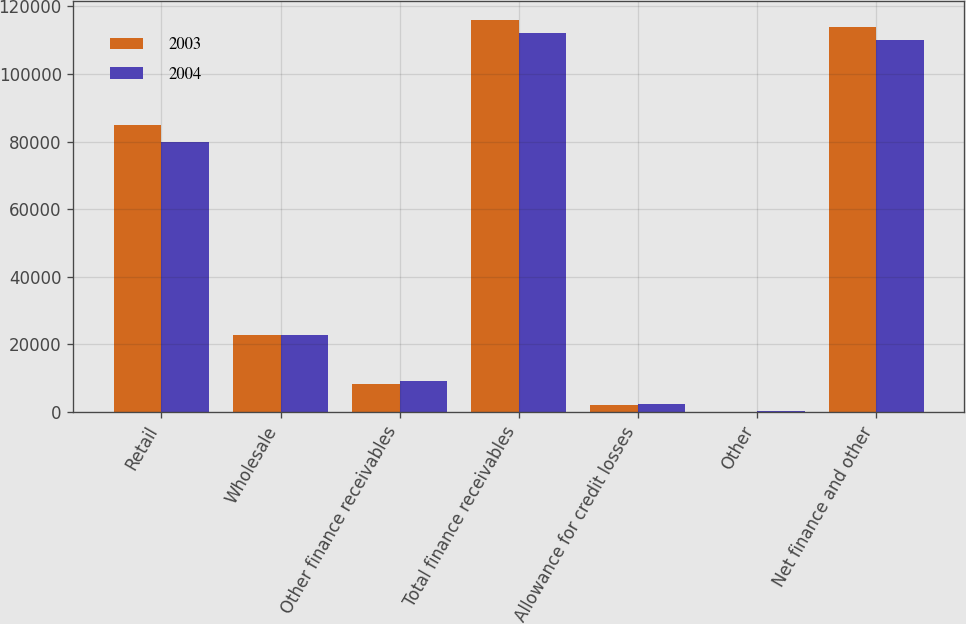Convert chart. <chart><loc_0><loc_0><loc_500><loc_500><stacked_bar_chart><ecel><fcel>Retail<fcel>Wholesale<fcel>Other finance receivables<fcel>Total finance receivables<fcel>Allowance for credit losses<fcel>Other<fcel>Net finance and other<nl><fcel>2003<fcel>84843<fcel>22666<fcel>8409<fcel>115918<fcel>2166<fcel>72<fcel>113824<nl><fcel>2004<fcel>80017<fcel>22910<fcel>9083<fcel>112010<fcel>2338<fcel>331<fcel>110003<nl></chart> 